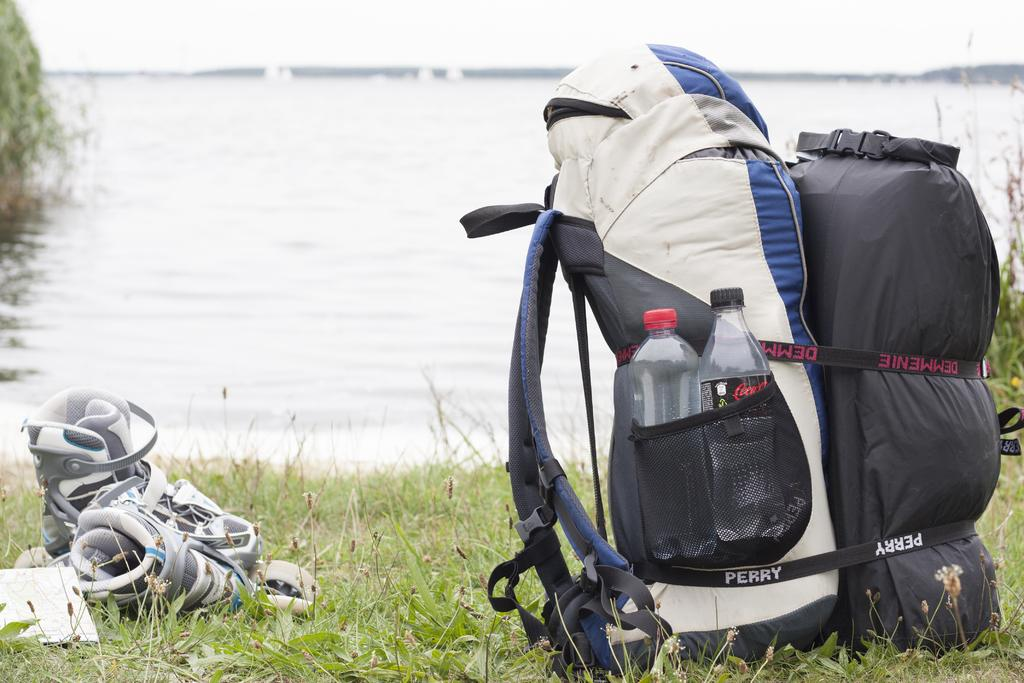<image>
Share a concise interpretation of the image provided. A Perry backpack holds a Coca Cola bottle in its side pocket 